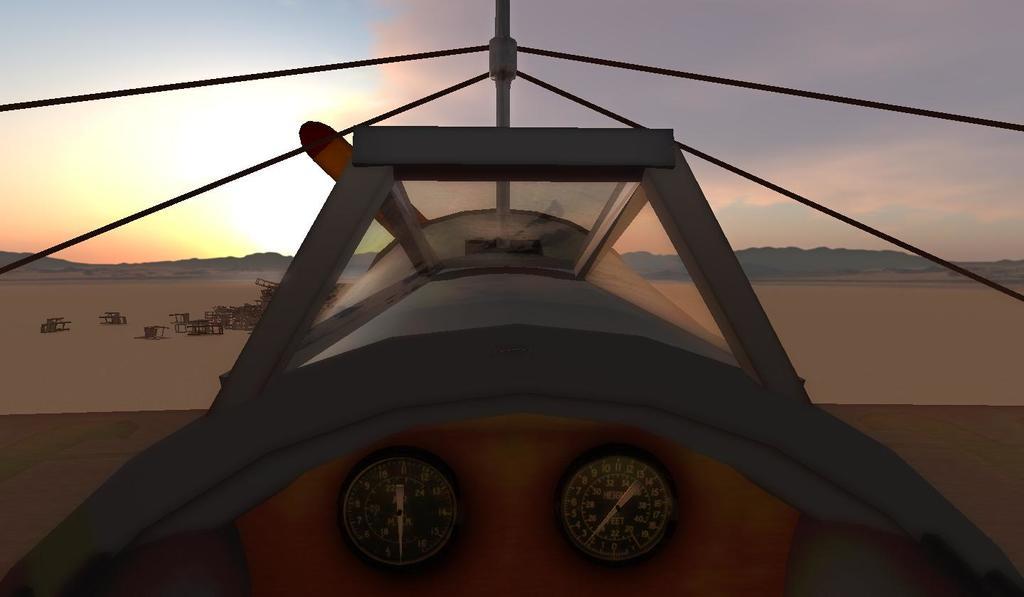What number is the gauge on the right showing?
Give a very brief answer. 2. 